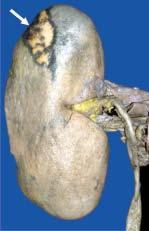what lies internally?
Answer the question using a single word or phrase. The apex 